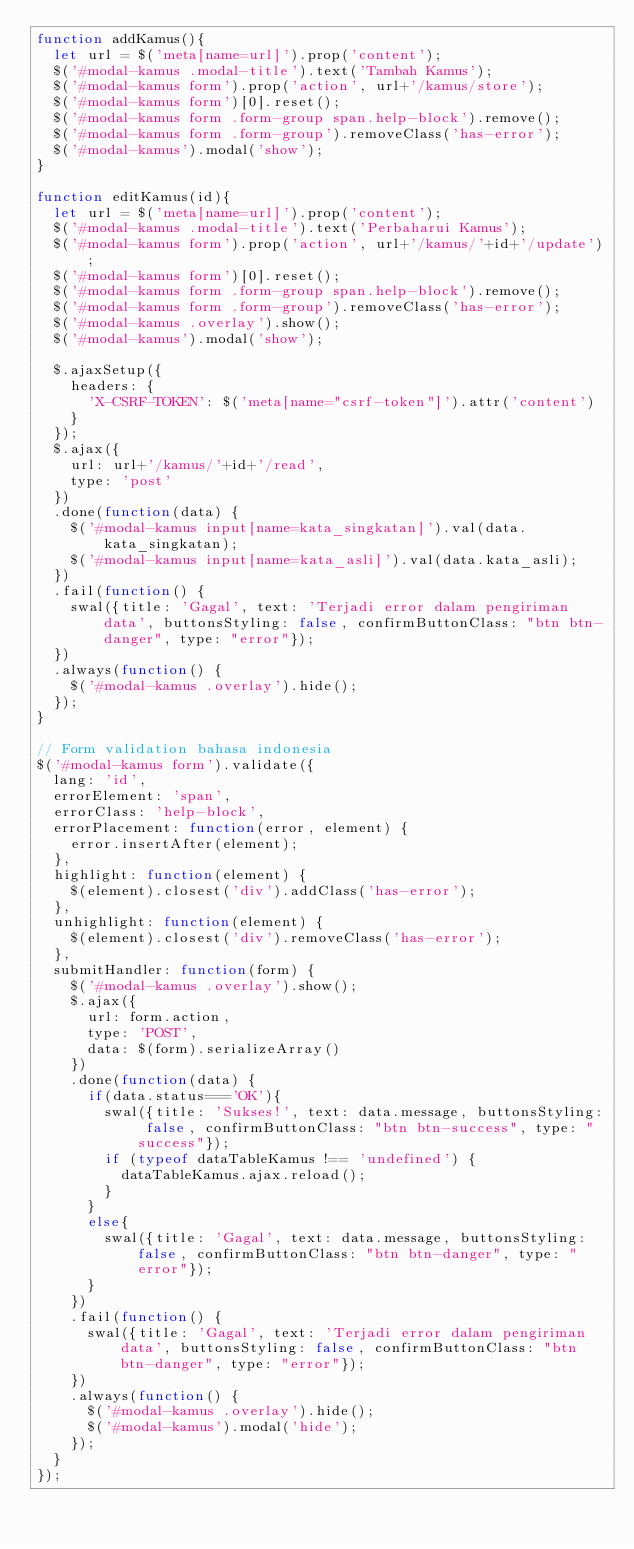Convert code to text. <code><loc_0><loc_0><loc_500><loc_500><_JavaScript_>function addKamus(){
  let url = $('meta[name=url]').prop('content');
  $('#modal-kamus .modal-title').text('Tambah Kamus');
  $('#modal-kamus form').prop('action', url+'/kamus/store');
  $('#modal-kamus form')[0].reset();
  $('#modal-kamus form .form-group span.help-block').remove();
  $('#modal-kamus form .form-group').removeClass('has-error');
  $('#modal-kamus').modal('show');
}

function editKamus(id){
  let url = $('meta[name=url]').prop('content');
  $('#modal-kamus .modal-title').text('Perbaharui Kamus');
  $('#modal-kamus form').prop('action', url+'/kamus/'+id+'/update');
  $('#modal-kamus form')[0].reset();
  $('#modal-kamus form .form-group span.help-block').remove();
  $('#modal-kamus form .form-group').removeClass('has-error');
  $('#modal-kamus .overlay').show();
  $('#modal-kamus').modal('show');

  $.ajaxSetup({
    headers: {
      'X-CSRF-TOKEN': $('meta[name="csrf-token"]').attr('content')
    }
  });
  $.ajax({
    url: url+'/kamus/'+id+'/read',
    type: 'post'
  })
  .done(function(data) {
    $('#modal-kamus input[name=kata_singkatan]').val(data.kata_singkatan);
    $('#modal-kamus input[name=kata_asli]').val(data.kata_asli);
  })
  .fail(function() {
    swal({title: 'Gagal', text: 'Terjadi error dalam pengiriman data', buttonsStyling: false, confirmButtonClass: "btn btn-danger", type: "error"});
  })
  .always(function() {
    $('#modal-kamus .overlay').hide();
  });
}

// Form validation bahasa indonesia
$('#modal-kamus form').validate({
  lang: 'id',
  errorElement: 'span',
  errorClass: 'help-block',
  errorPlacement: function(error, element) {
    error.insertAfter(element);
  },
  highlight: function(element) {
    $(element).closest('div').addClass('has-error');
  },
  unhighlight: function(element) {
    $(element).closest('div').removeClass('has-error');
  },
  submitHandler: function(form) {
    $('#modal-kamus .overlay').show();
    $.ajax({
      url: form.action,
      type: 'POST',
      data: $(form).serializeArray()
    })
    .done(function(data) {
      if(data.status==='OK'){
        swal({title: 'Sukses!', text: data.message, buttonsStyling: false, confirmButtonClass: "btn btn-success", type: "success"});
        if (typeof dataTableKamus !== 'undefined') {
          dataTableKamus.ajax.reload();
        }
      }
      else{
        swal({title: 'Gagal', text: data.message, buttonsStyling: false, confirmButtonClass: "btn btn-danger", type: "error"});
      }
    })
    .fail(function() {
      swal({title: 'Gagal', text: 'Terjadi error dalam pengiriman data', buttonsStyling: false, confirmButtonClass: "btn btn-danger", type: "error"});
    })
    .always(function() {
      $('#modal-kamus .overlay').hide();
      $('#modal-kamus').modal('hide');
    });
  }
});
</code> 